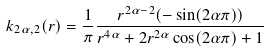Convert formula to latex. <formula><loc_0><loc_0><loc_500><loc_500>k _ { 2 \alpha , 2 } ( r ) = \frac { 1 } { \pi } \frac { r ^ { 2 \alpha - 2 } ( - \sin ( 2 \alpha \pi ) ) } { r ^ { 4 \alpha } + 2 r ^ { 2 \alpha } \cos ( 2 \alpha \pi ) + 1 }</formula> 